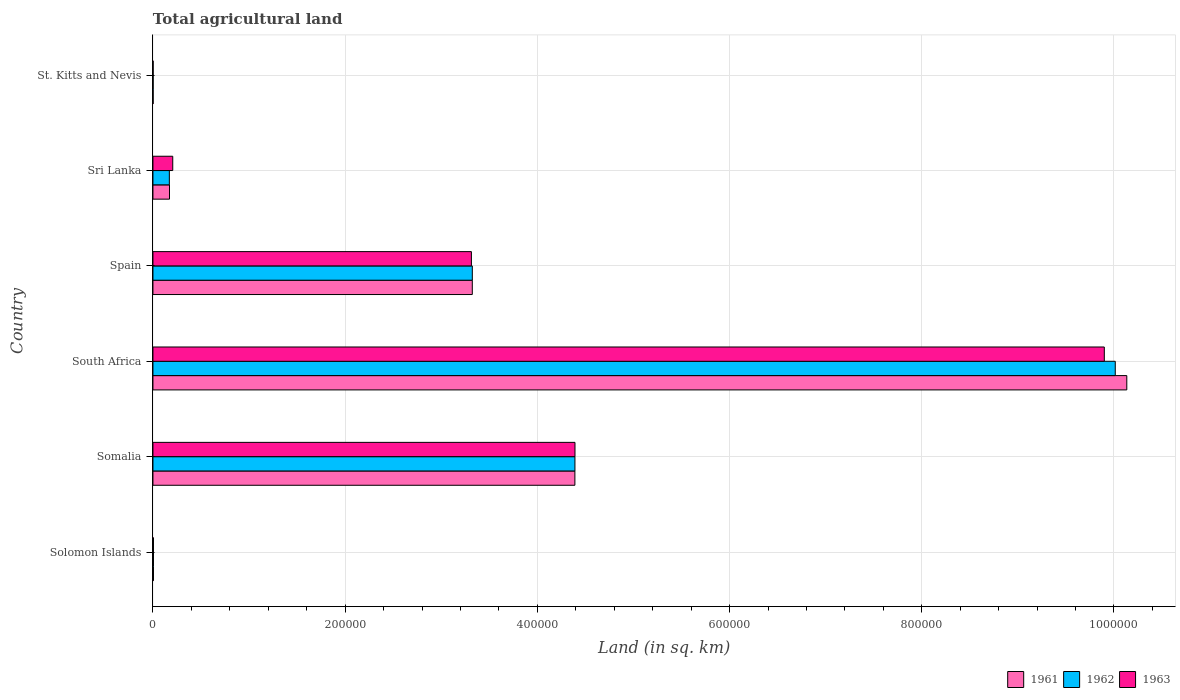Are the number of bars per tick equal to the number of legend labels?
Offer a very short reply. Yes. How many bars are there on the 5th tick from the top?
Your response must be concise. 3. How many bars are there on the 4th tick from the bottom?
Make the answer very short. 3. What is the label of the 2nd group of bars from the top?
Keep it short and to the point. Sri Lanka. In how many cases, is the number of bars for a given country not equal to the number of legend labels?
Provide a short and direct response. 0. What is the total agricultural land in 1962 in South Africa?
Give a very brief answer. 1.00e+06. Across all countries, what is the maximum total agricultural land in 1961?
Give a very brief answer. 1.01e+06. In which country was the total agricultural land in 1961 maximum?
Your response must be concise. South Africa. In which country was the total agricultural land in 1962 minimum?
Your answer should be compact. St. Kitts and Nevis. What is the total total agricultural land in 1962 in the graph?
Your response must be concise. 1.79e+06. What is the difference between the total agricultural land in 1962 in Solomon Islands and that in Somalia?
Ensure brevity in your answer.  -4.39e+05. What is the difference between the total agricultural land in 1962 in Spain and the total agricultural land in 1961 in Solomon Islands?
Ensure brevity in your answer.  3.32e+05. What is the average total agricultural land in 1963 per country?
Your answer should be compact. 2.97e+05. What is the difference between the total agricultural land in 1961 and total agricultural land in 1962 in St. Kitts and Nevis?
Ensure brevity in your answer.  0. What is the ratio of the total agricultural land in 1963 in Solomon Islands to that in Somalia?
Provide a succinct answer. 0. Is the total agricultural land in 1963 in Solomon Islands less than that in South Africa?
Provide a short and direct response. Yes. What is the difference between the highest and the second highest total agricultural land in 1961?
Offer a terse response. 5.74e+05. What is the difference between the highest and the lowest total agricultural land in 1961?
Ensure brevity in your answer.  1.01e+06. Is the sum of the total agricultural land in 1963 in Somalia and Spain greater than the maximum total agricultural land in 1962 across all countries?
Provide a short and direct response. No. Is it the case that in every country, the sum of the total agricultural land in 1963 and total agricultural land in 1962 is greater than the total agricultural land in 1961?
Your response must be concise. Yes. How many bars are there?
Offer a very short reply. 18. Are all the bars in the graph horizontal?
Your answer should be very brief. Yes. How many countries are there in the graph?
Your answer should be very brief. 6. What is the difference between two consecutive major ticks on the X-axis?
Your answer should be compact. 2.00e+05. Does the graph contain any zero values?
Offer a very short reply. No. Does the graph contain grids?
Keep it short and to the point. Yes. Where does the legend appear in the graph?
Your response must be concise. Bottom right. How many legend labels are there?
Provide a short and direct response. 3. How are the legend labels stacked?
Offer a terse response. Horizontal. What is the title of the graph?
Your answer should be very brief. Total agricultural land. What is the label or title of the X-axis?
Give a very brief answer. Land (in sq. km). What is the Land (in sq. km) in 1961 in Solomon Islands?
Provide a succinct answer. 550. What is the Land (in sq. km) in 1962 in Solomon Islands?
Keep it short and to the point. 550. What is the Land (in sq. km) in 1963 in Solomon Islands?
Your answer should be compact. 550. What is the Land (in sq. km) in 1961 in Somalia?
Give a very brief answer. 4.39e+05. What is the Land (in sq. km) in 1962 in Somalia?
Your answer should be very brief. 4.39e+05. What is the Land (in sq. km) in 1963 in Somalia?
Give a very brief answer. 4.39e+05. What is the Land (in sq. km) of 1961 in South Africa?
Make the answer very short. 1.01e+06. What is the Land (in sq. km) in 1962 in South Africa?
Offer a terse response. 1.00e+06. What is the Land (in sq. km) in 1963 in South Africa?
Offer a terse response. 9.90e+05. What is the Land (in sq. km) of 1961 in Spain?
Your response must be concise. 3.32e+05. What is the Land (in sq. km) of 1962 in Spain?
Keep it short and to the point. 3.32e+05. What is the Land (in sq. km) of 1963 in Spain?
Offer a very short reply. 3.31e+05. What is the Land (in sq. km) of 1961 in Sri Lanka?
Your answer should be compact. 1.72e+04. What is the Land (in sq. km) of 1962 in Sri Lanka?
Keep it short and to the point. 1.71e+04. What is the Land (in sq. km) of 1963 in Sri Lanka?
Give a very brief answer. 2.06e+04. What is the Land (in sq. km) of 1961 in St. Kitts and Nevis?
Your answer should be compact. 200. Across all countries, what is the maximum Land (in sq. km) of 1961?
Give a very brief answer. 1.01e+06. Across all countries, what is the maximum Land (in sq. km) of 1962?
Provide a short and direct response. 1.00e+06. Across all countries, what is the maximum Land (in sq. km) of 1963?
Offer a very short reply. 9.90e+05. Across all countries, what is the minimum Land (in sq. km) of 1963?
Give a very brief answer. 200. What is the total Land (in sq. km) of 1961 in the graph?
Your answer should be very brief. 1.80e+06. What is the total Land (in sq. km) of 1962 in the graph?
Your answer should be compact. 1.79e+06. What is the total Land (in sq. km) in 1963 in the graph?
Ensure brevity in your answer.  1.78e+06. What is the difference between the Land (in sq. km) of 1961 in Solomon Islands and that in Somalia?
Make the answer very short. -4.38e+05. What is the difference between the Land (in sq. km) of 1962 in Solomon Islands and that in Somalia?
Offer a very short reply. -4.39e+05. What is the difference between the Land (in sq. km) in 1963 in Solomon Islands and that in Somalia?
Provide a short and direct response. -4.39e+05. What is the difference between the Land (in sq. km) of 1961 in Solomon Islands and that in South Africa?
Offer a terse response. -1.01e+06. What is the difference between the Land (in sq. km) of 1962 in Solomon Islands and that in South Africa?
Give a very brief answer. -1.00e+06. What is the difference between the Land (in sq. km) in 1963 in Solomon Islands and that in South Africa?
Your answer should be very brief. -9.89e+05. What is the difference between the Land (in sq. km) of 1961 in Solomon Islands and that in Spain?
Ensure brevity in your answer.  -3.32e+05. What is the difference between the Land (in sq. km) in 1962 in Solomon Islands and that in Spain?
Give a very brief answer. -3.32e+05. What is the difference between the Land (in sq. km) of 1963 in Solomon Islands and that in Spain?
Ensure brevity in your answer.  -3.31e+05. What is the difference between the Land (in sq. km) of 1961 in Solomon Islands and that in Sri Lanka?
Your answer should be very brief. -1.67e+04. What is the difference between the Land (in sq. km) in 1962 in Solomon Islands and that in Sri Lanka?
Provide a short and direct response. -1.65e+04. What is the difference between the Land (in sq. km) in 1963 in Solomon Islands and that in Sri Lanka?
Make the answer very short. -2.00e+04. What is the difference between the Land (in sq. km) in 1961 in Solomon Islands and that in St. Kitts and Nevis?
Provide a short and direct response. 350. What is the difference between the Land (in sq. km) in 1962 in Solomon Islands and that in St. Kitts and Nevis?
Your answer should be very brief. 350. What is the difference between the Land (in sq. km) in 1963 in Solomon Islands and that in St. Kitts and Nevis?
Your response must be concise. 350. What is the difference between the Land (in sq. km) of 1961 in Somalia and that in South Africa?
Offer a terse response. -5.74e+05. What is the difference between the Land (in sq. km) of 1962 in Somalia and that in South Africa?
Your response must be concise. -5.62e+05. What is the difference between the Land (in sq. km) in 1963 in Somalia and that in South Africa?
Make the answer very short. -5.51e+05. What is the difference between the Land (in sq. km) in 1961 in Somalia and that in Spain?
Provide a succinct answer. 1.07e+05. What is the difference between the Land (in sq. km) in 1962 in Somalia and that in Spain?
Offer a terse response. 1.07e+05. What is the difference between the Land (in sq. km) of 1963 in Somalia and that in Spain?
Your answer should be compact. 1.08e+05. What is the difference between the Land (in sq. km) in 1961 in Somalia and that in Sri Lanka?
Give a very brief answer. 4.22e+05. What is the difference between the Land (in sq. km) of 1962 in Somalia and that in Sri Lanka?
Your answer should be compact. 4.22e+05. What is the difference between the Land (in sq. km) of 1963 in Somalia and that in Sri Lanka?
Provide a short and direct response. 4.19e+05. What is the difference between the Land (in sq. km) in 1961 in Somalia and that in St. Kitts and Nevis?
Offer a very short reply. 4.39e+05. What is the difference between the Land (in sq. km) in 1962 in Somalia and that in St. Kitts and Nevis?
Provide a short and direct response. 4.39e+05. What is the difference between the Land (in sq. km) in 1963 in Somalia and that in St. Kitts and Nevis?
Your response must be concise. 4.39e+05. What is the difference between the Land (in sq. km) of 1961 in South Africa and that in Spain?
Provide a short and direct response. 6.81e+05. What is the difference between the Land (in sq. km) of 1962 in South Africa and that in Spain?
Offer a terse response. 6.69e+05. What is the difference between the Land (in sq. km) in 1963 in South Africa and that in Spain?
Keep it short and to the point. 6.59e+05. What is the difference between the Land (in sq. km) of 1961 in South Africa and that in Sri Lanka?
Make the answer very short. 9.96e+05. What is the difference between the Land (in sq. km) of 1962 in South Africa and that in Sri Lanka?
Your answer should be compact. 9.84e+05. What is the difference between the Land (in sq. km) in 1963 in South Africa and that in Sri Lanka?
Provide a short and direct response. 9.69e+05. What is the difference between the Land (in sq. km) in 1961 in South Africa and that in St. Kitts and Nevis?
Offer a terse response. 1.01e+06. What is the difference between the Land (in sq. km) in 1962 in South Africa and that in St. Kitts and Nevis?
Provide a short and direct response. 1.00e+06. What is the difference between the Land (in sq. km) in 1963 in South Africa and that in St. Kitts and Nevis?
Provide a succinct answer. 9.90e+05. What is the difference between the Land (in sq. km) of 1961 in Spain and that in Sri Lanka?
Your answer should be very brief. 3.15e+05. What is the difference between the Land (in sq. km) in 1962 in Spain and that in Sri Lanka?
Offer a very short reply. 3.15e+05. What is the difference between the Land (in sq. km) in 1963 in Spain and that in Sri Lanka?
Your answer should be compact. 3.11e+05. What is the difference between the Land (in sq. km) in 1961 in Spain and that in St. Kitts and Nevis?
Your answer should be very brief. 3.32e+05. What is the difference between the Land (in sq. km) of 1962 in Spain and that in St. Kitts and Nevis?
Give a very brief answer. 3.32e+05. What is the difference between the Land (in sq. km) in 1963 in Spain and that in St. Kitts and Nevis?
Your answer should be very brief. 3.31e+05. What is the difference between the Land (in sq. km) in 1961 in Sri Lanka and that in St. Kitts and Nevis?
Offer a very short reply. 1.70e+04. What is the difference between the Land (in sq. km) in 1962 in Sri Lanka and that in St. Kitts and Nevis?
Give a very brief answer. 1.69e+04. What is the difference between the Land (in sq. km) of 1963 in Sri Lanka and that in St. Kitts and Nevis?
Give a very brief answer. 2.04e+04. What is the difference between the Land (in sq. km) in 1961 in Solomon Islands and the Land (in sq. km) in 1962 in Somalia?
Make the answer very short. -4.39e+05. What is the difference between the Land (in sq. km) of 1961 in Solomon Islands and the Land (in sq. km) of 1963 in Somalia?
Your answer should be compact. -4.39e+05. What is the difference between the Land (in sq. km) in 1962 in Solomon Islands and the Land (in sq. km) in 1963 in Somalia?
Keep it short and to the point. -4.39e+05. What is the difference between the Land (in sq. km) of 1961 in Solomon Islands and the Land (in sq. km) of 1962 in South Africa?
Your response must be concise. -1.00e+06. What is the difference between the Land (in sq. km) in 1961 in Solomon Islands and the Land (in sq. km) in 1963 in South Africa?
Keep it short and to the point. -9.89e+05. What is the difference between the Land (in sq. km) in 1962 in Solomon Islands and the Land (in sq. km) in 1963 in South Africa?
Keep it short and to the point. -9.89e+05. What is the difference between the Land (in sq. km) of 1961 in Solomon Islands and the Land (in sq. km) of 1962 in Spain?
Provide a succinct answer. -3.32e+05. What is the difference between the Land (in sq. km) of 1961 in Solomon Islands and the Land (in sq. km) of 1963 in Spain?
Make the answer very short. -3.31e+05. What is the difference between the Land (in sq. km) in 1962 in Solomon Islands and the Land (in sq. km) in 1963 in Spain?
Your answer should be compact. -3.31e+05. What is the difference between the Land (in sq. km) of 1961 in Solomon Islands and the Land (in sq. km) of 1962 in Sri Lanka?
Offer a terse response. -1.65e+04. What is the difference between the Land (in sq. km) in 1961 in Solomon Islands and the Land (in sq. km) in 1963 in Sri Lanka?
Offer a terse response. -2.00e+04. What is the difference between the Land (in sq. km) of 1962 in Solomon Islands and the Land (in sq. km) of 1963 in Sri Lanka?
Ensure brevity in your answer.  -2.00e+04. What is the difference between the Land (in sq. km) in 1961 in Solomon Islands and the Land (in sq. km) in 1962 in St. Kitts and Nevis?
Give a very brief answer. 350. What is the difference between the Land (in sq. km) of 1961 in Solomon Islands and the Land (in sq. km) of 1963 in St. Kitts and Nevis?
Give a very brief answer. 350. What is the difference between the Land (in sq. km) in 1962 in Solomon Islands and the Land (in sq. km) in 1963 in St. Kitts and Nevis?
Your response must be concise. 350. What is the difference between the Land (in sq. km) of 1961 in Somalia and the Land (in sq. km) of 1962 in South Africa?
Offer a very short reply. -5.62e+05. What is the difference between the Land (in sq. km) of 1961 in Somalia and the Land (in sq. km) of 1963 in South Africa?
Your answer should be compact. -5.51e+05. What is the difference between the Land (in sq. km) of 1962 in Somalia and the Land (in sq. km) of 1963 in South Africa?
Make the answer very short. -5.51e+05. What is the difference between the Land (in sq. km) in 1961 in Somalia and the Land (in sq. km) in 1962 in Spain?
Give a very brief answer. 1.07e+05. What is the difference between the Land (in sq. km) of 1961 in Somalia and the Land (in sq. km) of 1963 in Spain?
Give a very brief answer. 1.08e+05. What is the difference between the Land (in sq. km) of 1962 in Somalia and the Land (in sq. km) of 1963 in Spain?
Make the answer very short. 1.08e+05. What is the difference between the Land (in sq. km) in 1961 in Somalia and the Land (in sq. km) in 1962 in Sri Lanka?
Offer a terse response. 4.22e+05. What is the difference between the Land (in sq. km) in 1961 in Somalia and the Land (in sq. km) in 1963 in Sri Lanka?
Offer a terse response. 4.18e+05. What is the difference between the Land (in sq. km) in 1962 in Somalia and the Land (in sq. km) in 1963 in Sri Lanka?
Give a very brief answer. 4.18e+05. What is the difference between the Land (in sq. km) in 1961 in Somalia and the Land (in sq. km) in 1962 in St. Kitts and Nevis?
Keep it short and to the point. 4.39e+05. What is the difference between the Land (in sq. km) of 1961 in Somalia and the Land (in sq. km) of 1963 in St. Kitts and Nevis?
Your answer should be compact. 4.39e+05. What is the difference between the Land (in sq. km) in 1962 in Somalia and the Land (in sq. km) in 1963 in St. Kitts and Nevis?
Your response must be concise. 4.39e+05. What is the difference between the Land (in sq. km) of 1961 in South Africa and the Land (in sq. km) of 1962 in Spain?
Keep it short and to the point. 6.81e+05. What is the difference between the Land (in sq. km) of 1961 in South Africa and the Land (in sq. km) of 1963 in Spain?
Make the answer very short. 6.82e+05. What is the difference between the Land (in sq. km) in 1962 in South Africa and the Land (in sq. km) in 1963 in Spain?
Give a very brief answer. 6.70e+05. What is the difference between the Land (in sq. km) in 1961 in South Africa and the Land (in sq. km) in 1962 in Sri Lanka?
Make the answer very short. 9.96e+05. What is the difference between the Land (in sq. km) in 1961 in South Africa and the Land (in sq. km) in 1963 in Sri Lanka?
Make the answer very short. 9.93e+05. What is the difference between the Land (in sq. km) of 1962 in South Africa and the Land (in sq. km) of 1963 in Sri Lanka?
Your response must be concise. 9.81e+05. What is the difference between the Land (in sq. km) in 1961 in South Africa and the Land (in sq. km) in 1962 in St. Kitts and Nevis?
Your response must be concise. 1.01e+06. What is the difference between the Land (in sq. km) in 1961 in South Africa and the Land (in sq. km) in 1963 in St. Kitts and Nevis?
Your answer should be compact. 1.01e+06. What is the difference between the Land (in sq. km) in 1962 in South Africa and the Land (in sq. km) in 1963 in St. Kitts and Nevis?
Your response must be concise. 1.00e+06. What is the difference between the Land (in sq. km) of 1961 in Spain and the Land (in sq. km) of 1962 in Sri Lanka?
Ensure brevity in your answer.  3.15e+05. What is the difference between the Land (in sq. km) of 1961 in Spain and the Land (in sq. km) of 1963 in Sri Lanka?
Your answer should be compact. 3.12e+05. What is the difference between the Land (in sq. km) in 1962 in Spain and the Land (in sq. km) in 1963 in Sri Lanka?
Make the answer very short. 3.12e+05. What is the difference between the Land (in sq. km) of 1961 in Spain and the Land (in sq. km) of 1962 in St. Kitts and Nevis?
Keep it short and to the point. 3.32e+05. What is the difference between the Land (in sq. km) in 1961 in Spain and the Land (in sq. km) in 1963 in St. Kitts and Nevis?
Offer a very short reply. 3.32e+05. What is the difference between the Land (in sq. km) of 1962 in Spain and the Land (in sq. km) of 1963 in St. Kitts and Nevis?
Provide a short and direct response. 3.32e+05. What is the difference between the Land (in sq. km) of 1961 in Sri Lanka and the Land (in sq. km) of 1962 in St. Kitts and Nevis?
Offer a very short reply. 1.70e+04. What is the difference between the Land (in sq. km) of 1961 in Sri Lanka and the Land (in sq. km) of 1963 in St. Kitts and Nevis?
Offer a very short reply. 1.70e+04. What is the difference between the Land (in sq. km) of 1962 in Sri Lanka and the Land (in sq. km) of 1963 in St. Kitts and Nevis?
Provide a short and direct response. 1.69e+04. What is the average Land (in sq. km) in 1961 per country?
Offer a terse response. 3.00e+05. What is the average Land (in sq. km) of 1962 per country?
Offer a very short reply. 2.98e+05. What is the average Land (in sq. km) of 1963 per country?
Provide a short and direct response. 2.97e+05. What is the difference between the Land (in sq. km) in 1961 and Land (in sq. km) in 1963 in Solomon Islands?
Provide a succinct answer. 0. What is the difference between the Land (in sq. km) of 1961 and Land (in sq. km) of 1963 in Somalia?
Your response must be concise. -100. What is the difference between the Land (in sq. km) of 1962 and Land (in sq. km) of 1963 in Somalia?
Your answer should be very brief. -50. What is the difference between the Land (in sq. km) in 1961 and Land (in sq. km) in 1962 in South Africa?
Your answer should be compact. 1.20e+04. What is the difference between the Land (in sq. km) in 1961 and Land (in sq. km) in 1963 in South Africa?
Your answer should be very brief. 2.34e+04. What is the difference between the Land (in sq. km) in 1962 and Land (in sq. km) in 1963 in South Africa?
Keep it short and to the point. 1.14e+04. What is the difference between the Land (in sq. km) of 1961 and Land (in sq. km) of 1962 in Spain?
Make the answer very short. -20. What is the difference between the Land (in sq. km) in 1961 and Land (in sq. km) in 1963 in Spain?
Make the answer very short. 930. What is the difference between the Land (in sq. km) in 1962 and Land (in sq. km) in 1963 in Spain?
Give a very brief answer. 950. What is the difference between the Land (in sq. km) in 1961 and Land (in sq. km) in 1962 in Sri Lanka?
Offer a terse response. 160. What is the difference between the Land (in sq. km) of 1961 and Land (in sq. km) of 1963 in Sri Lanka?
Keep it short and to the point. -3370. What is the difference between the Land (in sq. km) of 1962 and Land (in sq. km) of 1963 in Sri Lanka?
Offer a terse response. -3530. What is the difference between the Land (in sq. km) in 1962 and Land (in sq. km) in 1963 in St. Kitts and Nevis?
Your answer should be very brief. 0. What is the ratio of the Land (in sq. km) in 1961 in Solomon Islands to that in Somalia?
Offer a terse response. 0. What is the ratio of the Land (in sq. km) in 1962 in Solomon Islands to that in Somalia?
Give a very brief answer. 0. What is the ratio of the Land (in sq. km) in 1963 in Solomon Islands to that in Somalia?
Give a very brief answer. 0. What is the ratio of the Land (in sq. km) in 1961 in Solomon Islands to that in South Africa?
Provide a succinct answer. 0. What is the ratio of the Land (in sq. km) in 1962 in Solomon Islands to that in South Africa?
Your answer should be compact. 0. What is the ratio of the Land (in sq. km) in 1963 in Solomon Islands to that in South Africa?
Provide a short and direct response. 0. What is the ratio of the Land (in sq. km) of 1961 in Solomon Islands to that in Spain?
Ensure brevity in your answer.  0. What is the ratio of the Land (in sq. km) of 1962 in Solomon Islands to that in Spain?
Ensure brevity in your answer.  0. What is the ratio of the Land (in sq. km) of 1963 in Solomon Islands to that in Spain?
Your response must be concise. 0. What is the ratio of the Land (in sq. km) in 1961 in Solomon Islands to that in Sri Lanka?
Give a very brief answer. 0.03. What is the ratio of the Land (in sq. km) of 1962 in Solomon Islands to that in Sri Lanka?
Provide a short and direct response. 0.03. What is the ratio of the Land (in sq. km) of 1963 in Solomon Islands to that in Sri Lanka?
Your answer should be very brief. 0.03. What is the ratio of the Land (in sq. km) in 1961 in Solomon Islands to that in St. Kitts and Nevis?
Keep it short and to the point. 2.75. What is the ratio of the Land (in sq. km) of 1962 in Solomon Islands to that in St. Kitts and Nevis?
Make the answer very short. 2.75. What is the ratio of the Land (in sq. km) of 1963 in Solomon Islands to that in St. Kitts and Nevis?
Keep it short and to the point. 2.75. What is the ratio of the Land (in sq. km) in 1961 in Somalia to that in South Africa?
Give a very brief answer. 0.43. What is the ratio of the Land (in sq. km) of 1962 in Somalia to that in South Africa?
Give a very brief answer. 0.44. What is the ratio of the Land (in sq. km) in 1963 in Somalia to that in South Africa?
Your answer should be compact. 0.44. What is the ratio of the Land (in sq. km) of 1961 in Somalia to that in Spain?
Make the answer very short. 1.32. What is the ratio of the Land (in sq. km) of 1962 in Somalia to that in Spain?
Your response must be concise. 1.32. What is the ratio of the Land (in sq. km) in 1963 in Somalia to that in Spain?
Your answer should be compact. 1.33. What is the ratio of the Land (in sq. km) of 1961 in Somalia to that in Sri Lanka?
Your answer should be very brief. 25.48. What is the ratio of the Land (in sq. km) in 1962 in Somalia to that in Sri Lanka?
Provide a short and direct response. 25.72. What is the ratio of the Land (in sq. km) of 1963 in Somalia to that in Sri Lanka?
Offer a very short reply. 21.32. What is the ratio of the Land (in sq. km) of 1961 in Somalia to that in St. Kitts and Nevis?
Your answer should be very brief. 2195.25. What is the ratio of the Land (in sq. km) in 1962 in Somalia to that in St. Kitts and Nevis?
Provide a short and direct response. 2195.5. What is the ratio of the Land (in sq. km) of 1963 in Somalia to that in St. Kitts and Nevis?
Provide a succinct answer. 2195.75. What is the ratio of the Land (in sq. km) in 1961 in South Africa to that in Spain?
Make the answer very short. 3.05. What is the ratio of the Land (in sq. km) in 1962 in South Africa to that in Spain?
Offer a terse response. 3.01. What is the ratio of the Land (in sq. km) in 1963 in South Africa to that in Spain?
Provide a succinct answer. 2.99. What is the ratio of the Land (in sq. km) of 1961 in South Africa to that in Sri Lanka?
Your answer should be very brief. 58.81. What is the ratio of the Land (in sq. km) of 1962 in South Africa to that in Sri Lanka?
Provide a succinct answer. 58.66. What is the ratio of the Land (in sq. km) of 1963 in South Africa to that in Sri Lanka?
Your response must be concise. 48.06. What is the ratio of the Land (in sq. km) of 1961 in South Africa to that in St. Kitts and Nevis?
Your answer should be compact. 5066.75. What is the ratio of the Land (in sq. km) of 1962 in South Africa to that in St. Kitts and Nevis?
Keep it short and to the point. 5006.75. What is the ratio of the Land (in sq. km) of 1963 in South Africa to that in St. Kitts and Nevis?
Your response must be concise. 4949.75. What is the ratio of the Land (in sq. km) of 1961 in Spain to that in Sri Lanka?
Ensure brevity in your answer.  19.29. What is the ratio of the Land (in sq. km) of 1962 in Spain to that in Sri Lanka?
Offer a very short reply. 19.47. What is the ratio of the Land (in sq. km) of 1963 in Spain to that in Sri Lanka?
Offer a very short reply. 16.09. What is the ratio of the Land (in sq. km) of 1961 in Spain to that in St. Kitts and Nevis?
Give a very brief answer. 1661.5. What is the ratio of the Land (in sq. km) of 1962 in Spain to that in St. Kitts and Nevis?
Your answer should be compact. 1661.6. What is the ratio of the Land (in sq. km) in 1963 in Spain to that in St. Kitts and Nevis?
Give a very brief answer. 1656.85. What is the ratio of the Land (in sq. km) of 1961 in Sri Lanka to that in St. Kitts and Nevis?
Make the answer very short. 86.15. What is the ratio of the Land (in sq. km) of 1962 in Sri Lanka to that in St. Kitts and Nevis?
Offer a very short reply. 85.35. What is the ratio of the Land (in sq. km) in 1963 in Sri Lanka to that in St. Kitts and Nevis?
Ensure brevity in your answer.  103. What is the difference between the highest and the second highest Land (in sq. km) of 1961?
Ensure brevity in your answer.  5.74e+05. What is the difference between the highest and the second highest Land (in sq. km) in 1962?
Your answer should be very brief. 5.62e+05. What is the difference between the highest and the second highest Land (in sq. km) in 1963?
Offer a very short reply. 5.51e+05. What is the difference between the highest and the lowest Land (in sq. km) of 1961?
Offer a very short reply. 1.01e+06. What is the difference between the highest and the lowest Land (in sq. km) of 1962?
Make the answer very short. 1.00e+06. What is the difference between the highest and the lowest Land (in sq. km) in 1963?
Keep it short and to the point. 9.90e+05. 